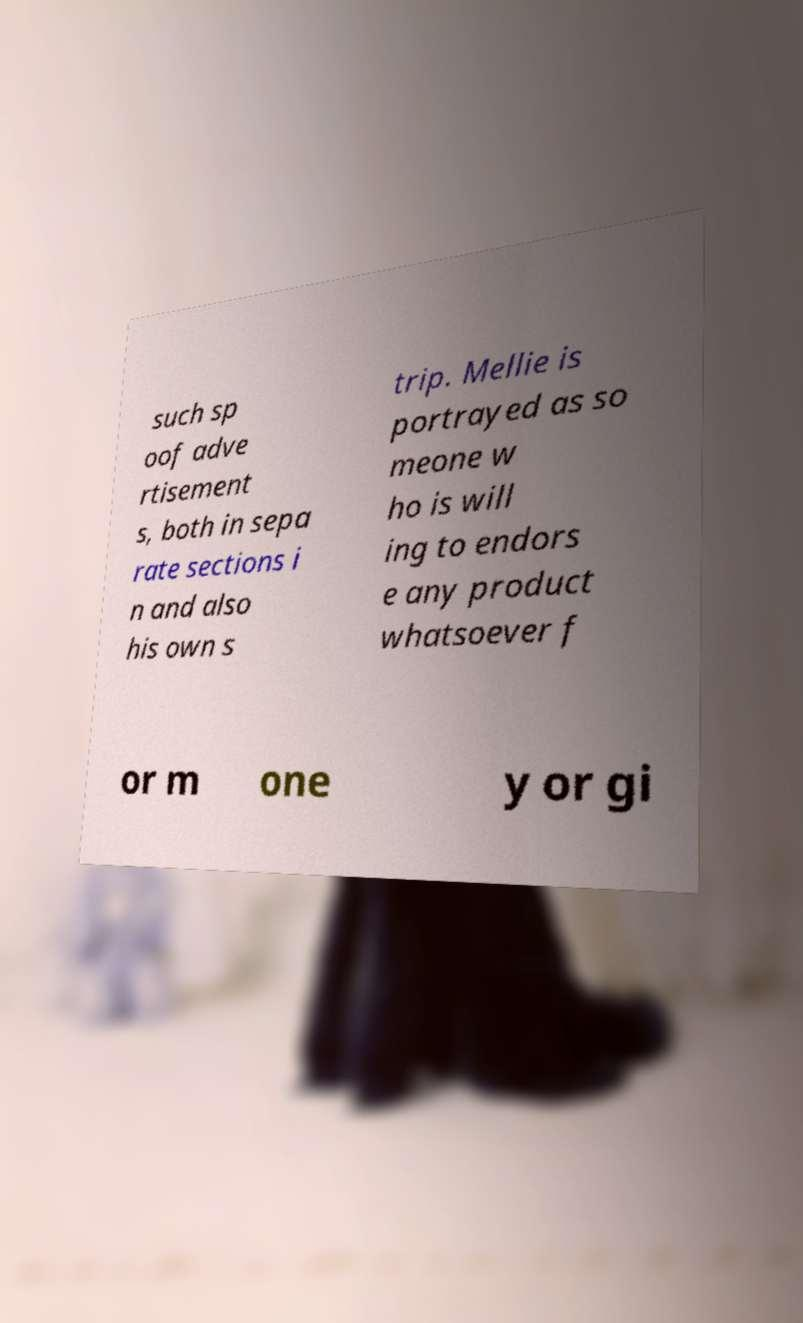Please identify and transcribe the text found in this image. such sp oof adve rtisement s, both in sepa rate sections i n and also his own s trip. Mellie is portrayed as so meone w ho is will ing to endors e any product whatsoever f or m one y or gi 